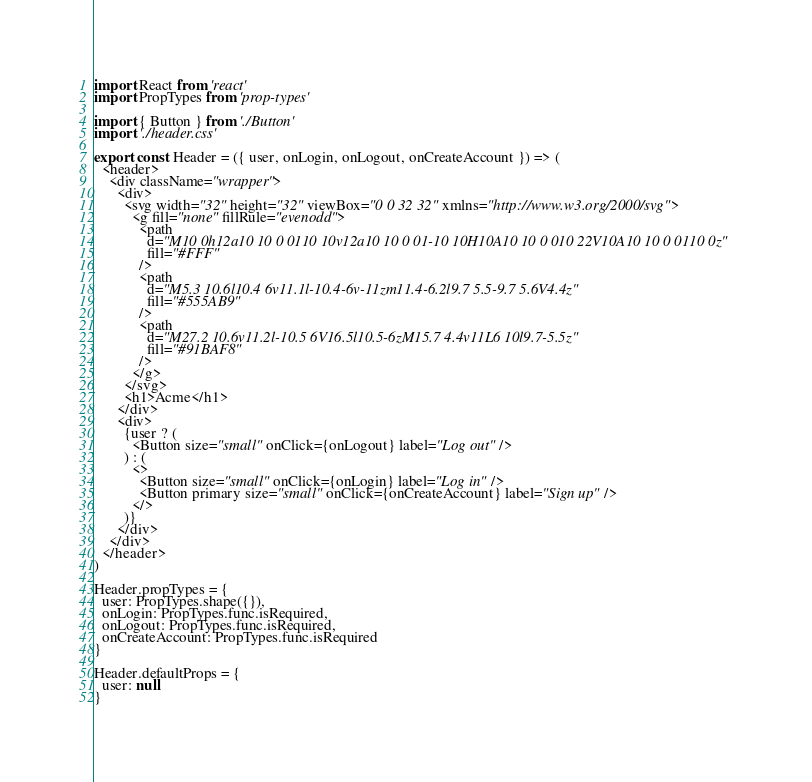<code> <loc_0><loc_0><loc_500><loc_500><_JavaScript_>import React from 'react'
import PropTypes from 'prop-types'

import { Button } from './Button'
import './header.css'

export const Header = ({ user, onLogin, onLogout, onCreateAccount }) => (
  <header>
    <div className="wrapper">
      <div>
        <svg width="32" height="32" viewBox="0 0 32 32" xmlns="http://www.w3.org/2000/svg">
          <g fill="none" fillRule="evenodd">
            <path
              d="M10 0h12a10 10 0 0110 10v12a10 10 0 01-10 10H10A10 10 0 010 22V10A10 10 0 0110 0z"
              fill="#FFF"
            />
            <path
              d="M5.3 10.6l10.4 6v11.1l-10.4-6v-11zm11.4-6.2l9.7 5.5-9.7 5.6V4.4z"
              fill="#555AB9"
            />
            <path
              d="M27.2 10.6v11.2l-10.5 6V16.5l10.5-6zM15.7 4.4v11L6 10l9.7-5.5z"
              fill="#91BAF8"
            />
          </g>
        </svg>
        <h1>Acme</h1>
      </div>
      <div>
        {user ? (
          <Button size="small" onClick={onLogout} label="Log out" />
        ) : (
          <>
            <Button size="small" onClick={onLogin} label="Log in" />
            <Button primary size="small" onClick={onCreateAccount} label="Sign up" />
          </>
        )}
      </div>
    </div>
  </header>
)

Header.propTypes = {
  user: PropTypes.shape({}),
  onLogin: PropTypes.func.isRequired,
  onLogout: PropTypes.func.isRequired,
  onCreateAccount: PropTypes.func.isRequired
}

Header.defaultProps = {
  user: null
}
</code> 